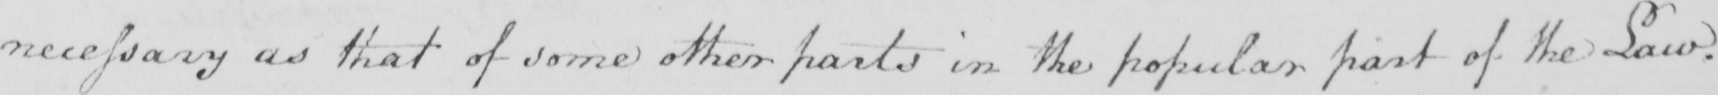Can you tell me what this handwritten text says? necessary as that of some other parts in the popular part of the Law . 